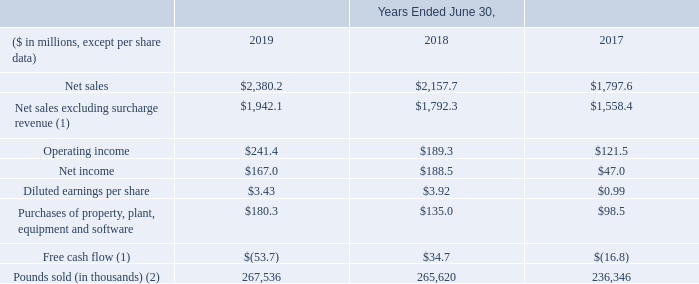Business Trends
Selected financial results for the past three fiscal years are summarized below:
(1) See the section “Non-GAAP Financial Measures” below for further discussion of these financial measures.
(2) Includes pounds from Specialty Alloys Operations segment, and certain Performance Engineered Products segment businesses including Dynamet, Carpenter Powder Products and LPW Technology Ltd.
Where can further information on free cash flow and net sales excluding surcharge revenue be found? See the section “non-gaap financial measures”. What does the amount of Pounds sold include? Includes pounds from specialty alloys operations segment, and certain performance engineered products segment businesses including dynamet, carpenter powder products and lpw technology ltd. In which years was Net income calculated? 2019, 2018, 2017. In which year was the diluted earnings per share largest? 3.92>3.43>0.99
Answer: 2018. What was the change in Purchases of property, plant, equipment and software in 2019 from 2018?
Answer scale should be: million. 180.3-135.0
Answer: 45.3. What was the percentage change in Purchases of property, plant, equipment and software in 2019 from 2018?
Answer scale should be: percent. (180.3-135.0)/135.0
Answer: 33.56. 